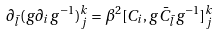<formula> <loc_0><loc_0><loc_500><loc_500>\partial _ { \bar { l } } ( g \partial _ { i } g ^ { - 1 } ) _ { j } ^ { k } = \beta ^ { 2 } [ C _ { i } , g { \bar { C } } _ { \bar { l } } g ^ { - 1 } ] _ { j } ^ { k }</formula> 